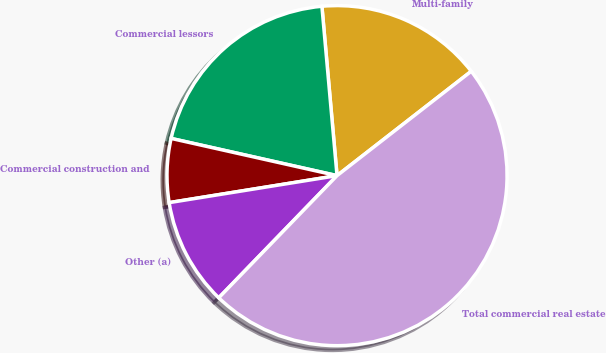<chart> <loc_0><loc_0><loc_500><loc_500><pie_chart><fcel>Multi-family<fcel>Commercial lessors<fcel>Commercial construction and<fcel>Other (a)<fcel>Total commercial real estate<nl><fcel>15.9%<fcel>20.07%<fcel>6.05%<fcel>10.22%<fcel>47.76%<nl></chart> 